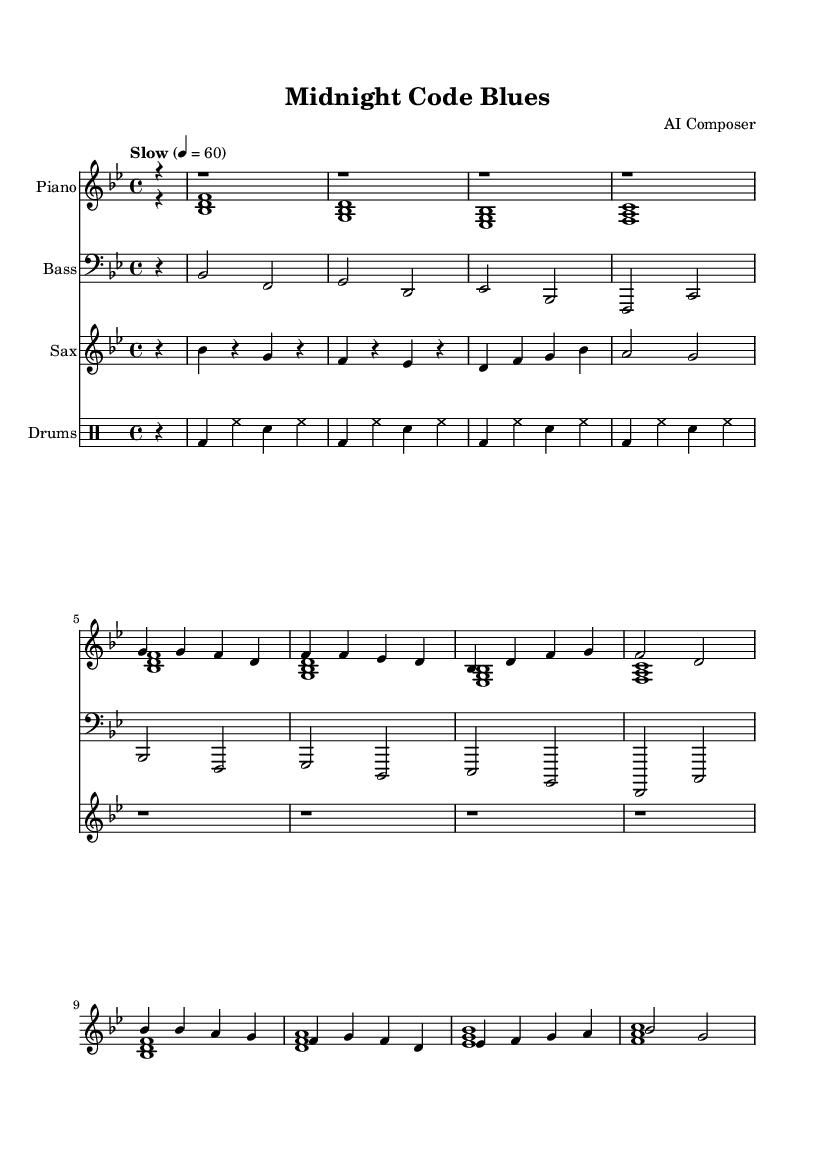What is the key signature of this music? The key signature is B flat major, which has two flats (B flat and E flat). This can be confirmed by looking at the beginning of the staff where the sharps and flats are indicated.
Answer: B flat major What is the time signature of this music? The time signature is 4/4, which indicates four beats per measure. This is evident at the beginning of the score where the time signature is marked.
Answer: 4/4 What is the tempo marking for this piece? The tempo marking is "Slow" with a metronome mark of quarter note equals 60. This is provided in the header section of the music.
Answer: Slow, 60 How many sections are in the music, excluding the intro? There are two main sections in the music: the Verse and the Chorus. The structure is laid out with distinct lines for the Verse and Chorus after the introductory measures.
Answer: 2 What is the instrument labeled for the right hand? The instrument for the right hand is labeled as "Piano". This can be seen in the notation above the voice part that indicates instrument names.
Answer: Piano Which instrument plays the bass line in this score? The instrument that plays the bass line is labeled as "Bass". This label appears above the staff that contains the bass notes.
Answer: Bass What rhythmic pattern is used in the drum part? The drum part uses a steady pattern of bass drum and hi-hat, with snare in between, as shown in the drum staff notations. The rhythmic grouping can be analyzed by examining the sequence written in drum notation.
Answer: Bass and Hi-hat with Snare 